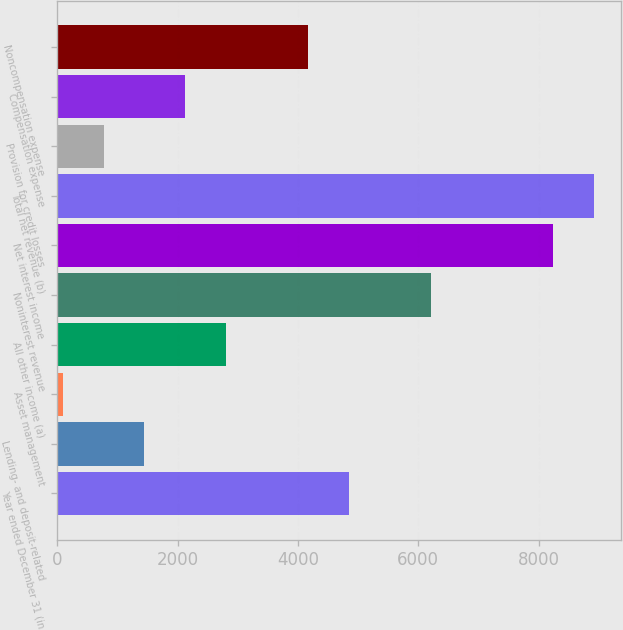Convert chart to OTSL. <chart><loc_0><loc_0><loc_500><loc_500><bar_chart><fcel>Year ended December 31 (in<fcel>Lending- and deposit-related<fcel>Asset management<fcel>All other income (a)<fcel>Noninterest revenue<fcel>Net interest income<fcel>Total net revenue (b)<fcel>Provision for credit losses<fcel>Compensation expense<fcel>Noncompensation expense<nl><fcel>4845.9<fcel>1447.4<fcel>88<fcel>2806.8<fcel>6205.3<fcel>8244.4<fcel>8924.1<fcel>767.7<fcel>2127.1<fcel>4166.2<nl></chart> 